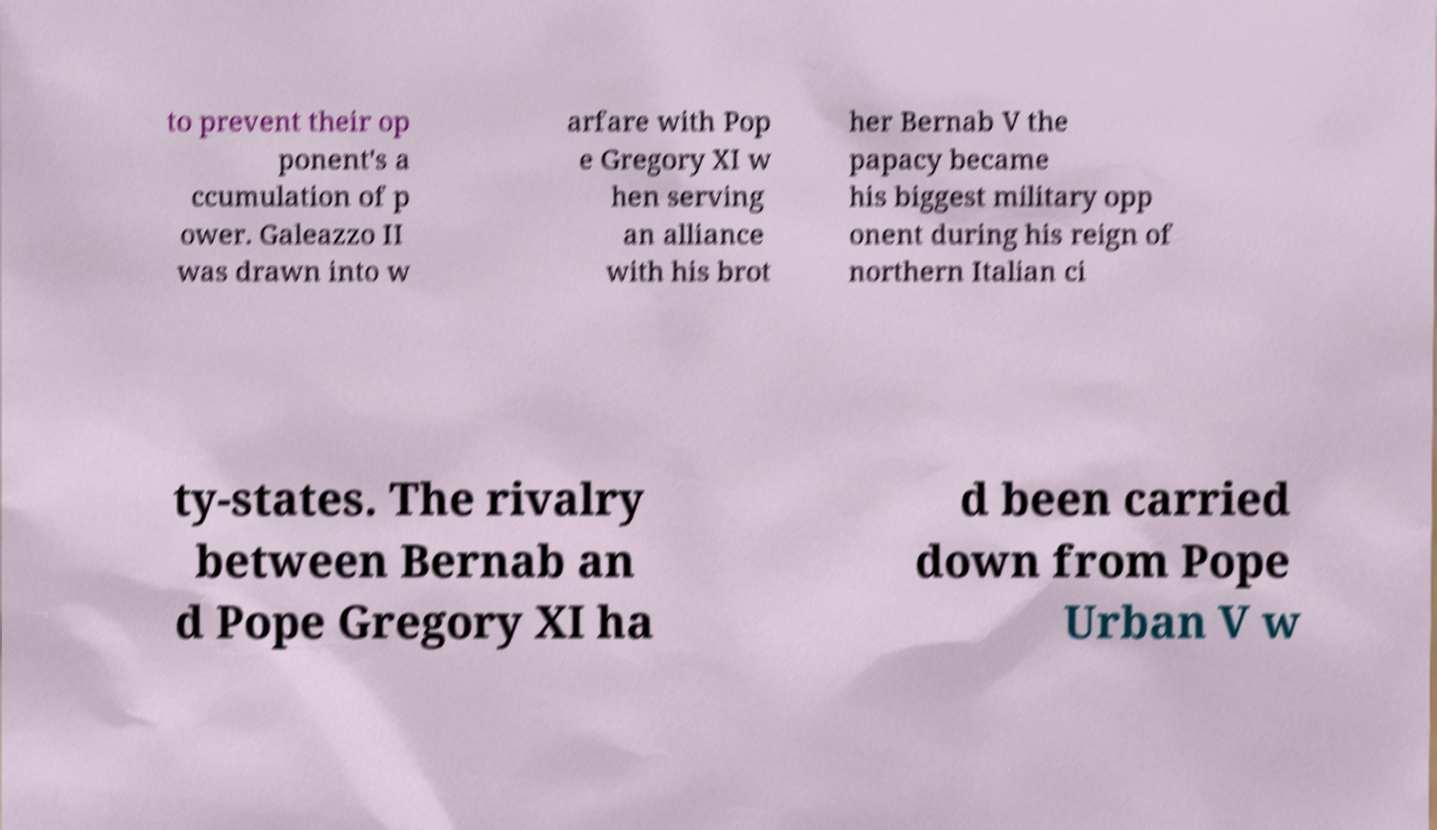What messages or text are displayed in this image? I need them in a readable, typed format. to prevent their op ponent's a ccumulation of p ower. Galeazzo II was drawn into w arfare with Pop e Gregory XI w hen serving an alliance with his brot her Bernab V the papacy became his biggest military opp onent during his reign of northern Italian ci ty-states. The rivalry between Bernab an d Pope Gregory XI ha d been carried down from Pope Urban V w 